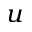Convert formula to latex. <formula><loc_0><loc_0><loc_500><loc_500>_ { u }</formula> 